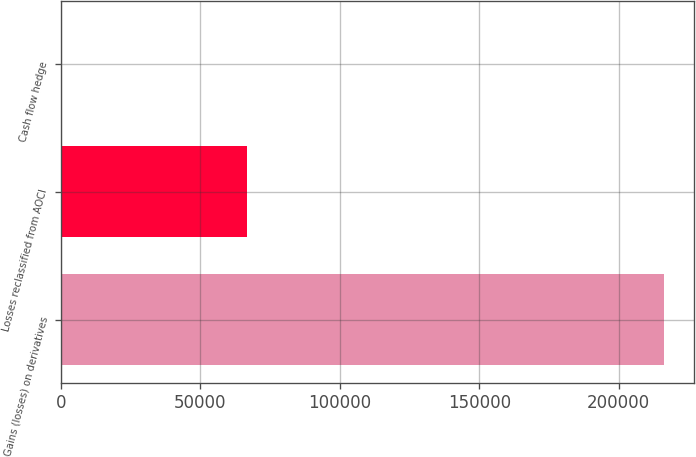<chart> <loc_0><loc_0><loc_500><loc_500><bar_chart><fcel>Gains (losses) on derivatives<fcel>Losses reclassified from AOCI<fcel>Cash flow hedge<nl><fcel>216302<fcel>66847<fcel>491<nl></chart> 